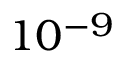Convert formula to latex. <formula><loc_0><loc_0><loc_500><loc_500>1 0 ^ { - 9 }</formula> 